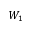Convert formula to latex. <formula><loc_0><loc_0><loc_500><loc_500>W _ { 1 }</formula> 